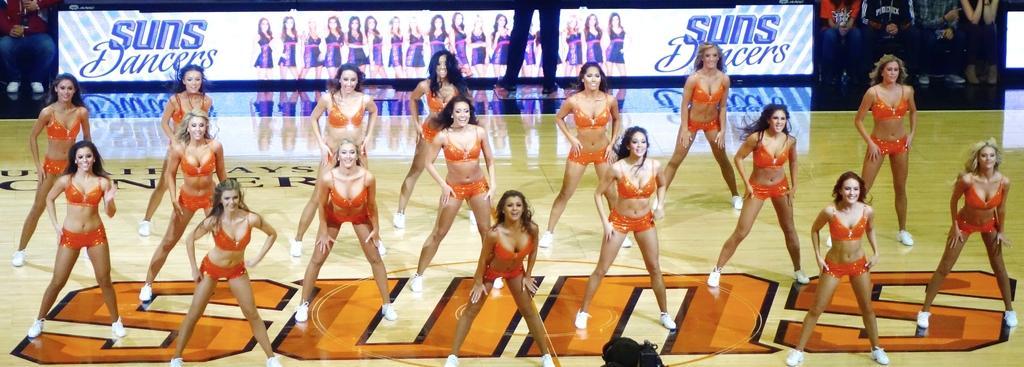Could you give a brief overview of what you see in this image? In the picture we can see some woman are dancing on the dance floor, they are with orange dance wear and behind them, we can see an advertisement of dance and behind it we can see some people are sitting and watching them. 